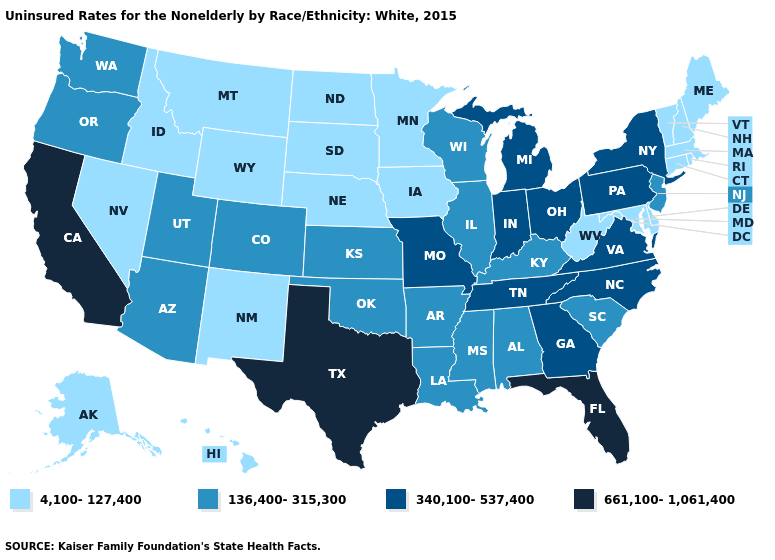Name the states that have a value in the range 136,400-315,300?
Write a very short answer. Alabama, Arizona, Arkansas, Colorado, Illinois, Kansas, Kentucky, Louisiana, Mississippi, New Jersey, Oklahoma, Oregon, South Carolina, Utah, Washington, Wisconsin. What is the value of Maryland?
Short answer required. 4,100-127,400. Does New York have the highest value in the USA?
Answer briefly. No. Name the states that have a value in the range 4,100-127,400?
Quick response, please. Alaska, Connecticut, Delaware, Hawaii, Idaho, Iowa, Maine, Maryland, Massachusetts, Minnesota, Montana, Nebraska, Nevada, New Hampshire, New Mexico, North Dakota, Rhode Island, South Dakota, Vermont, West Virginia, Wyoming. Does Maryland have the lowest value in the South?
Write a very short answer. Yes. What is the value of Nebraska?
Give a very brief answer. 4,100-127,400. What is the highest value in states that border Idaho?
Keep it brief. 136,400-315,300. Name the states that have a value in the range 4,100-127,400?
Be succinct. Alaska, Connecticut, Delaware, Hawaii, Idaho, Iowa, Maine, Maryland, Massachusetts, Minnesota, Montana, Nebraska, Nevada, New Hampshire, New Mexico, North Dakota, Rhode Island, South Dakota, Vermont, West Virginia, Wyoming. Which states have the highest value in the USA?
Give a very brief answer. California, Florida, Texas. Name the states that have a value in the range 136,400-315,300?
Short answer required. Alabama, Arizona, Arkansas, Colorado, Illinois, Kansas, Kentucky, Louisiana, Mississippi, New Jersey, Oklahoma, Oregon, South Carolina, Utah, Washington, Wisconsin. What is the highest value in states that border New York?
Short answer required. 340,100-537,400. What is the value of California?
Quick response, please. 661,100-1,061,400. What is the value of California?
Quick response, please. 661,100-1,061,400. Among the states that border Rhode Island , which have the lowest value?
Short answer required. Connecticut, Massachusetts. Among the states that border Pennsylvania , does New Jersey have the highest value?
Keep it brief. No. 